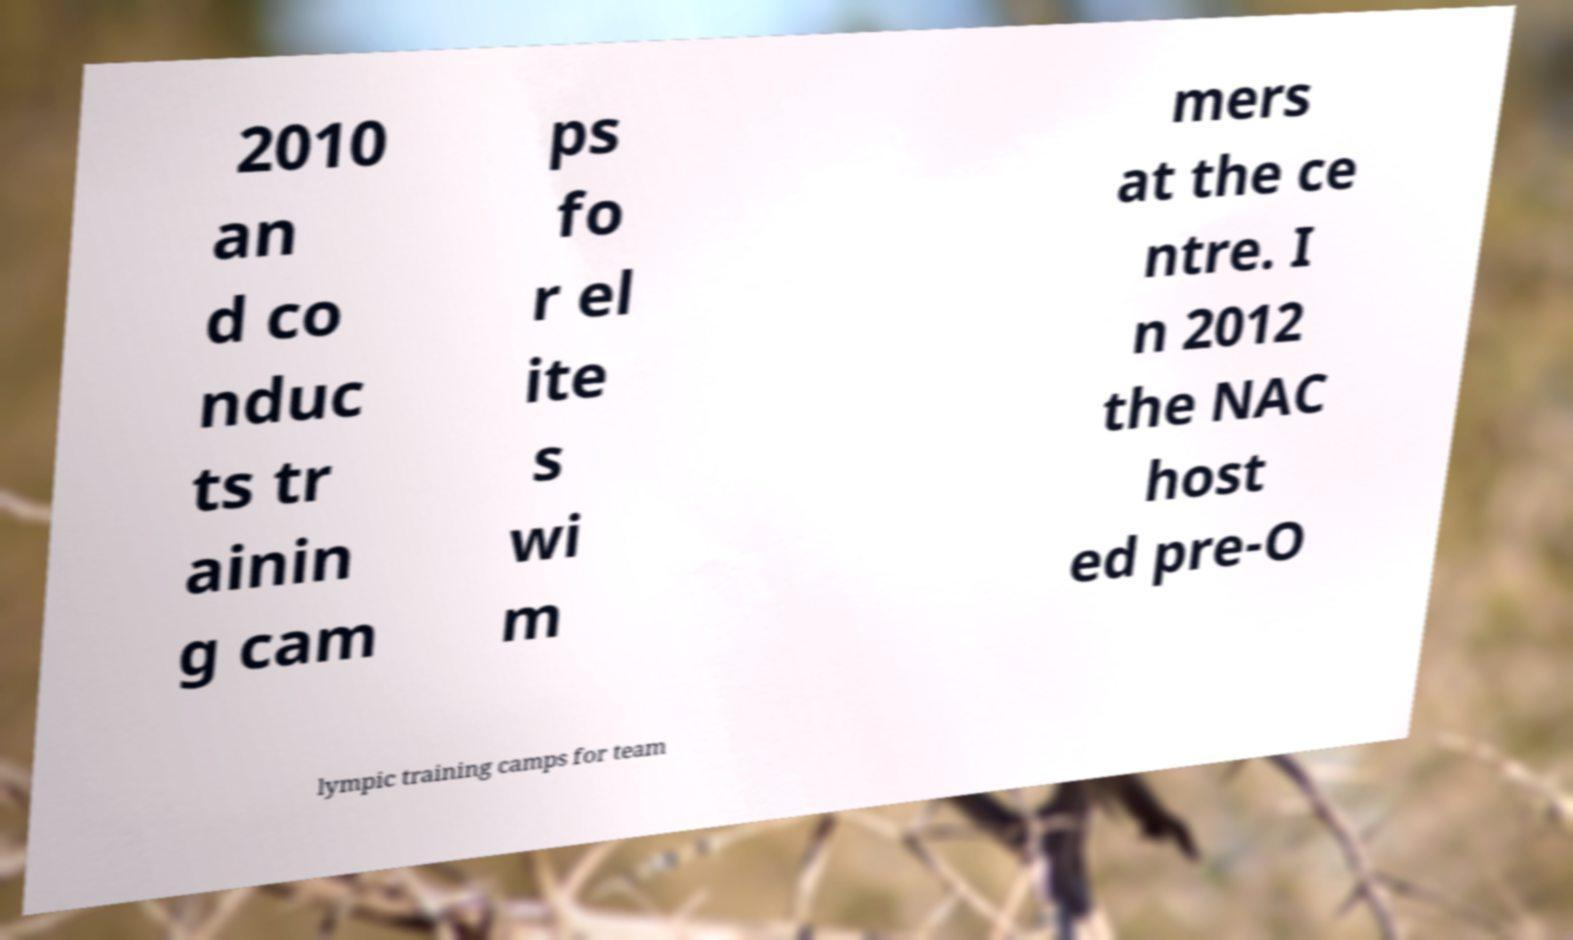Please identify and transcribe the text found in this image. 2010 an d co nduc ts tr ainin g cam ps fo r el ite s wi m mers at the ce ntre. I n 2012 the NAC host ed pre-O lympic training camps for team 